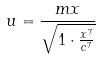Convert formula to latex. <formula><loc_0><loc_0><loc_500><loc_500>u = \frac { m x } { \sqrt { 1 \cdot \frac { x ^ { 7 } } { c ^ { 7 } } } }</formula> 